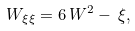<formula> <loc_0><loc_0><loc_500><loc_500>W _ { \xi \xi } = 6 \, W ^ { 2 } - \, \xi ,</formula> 